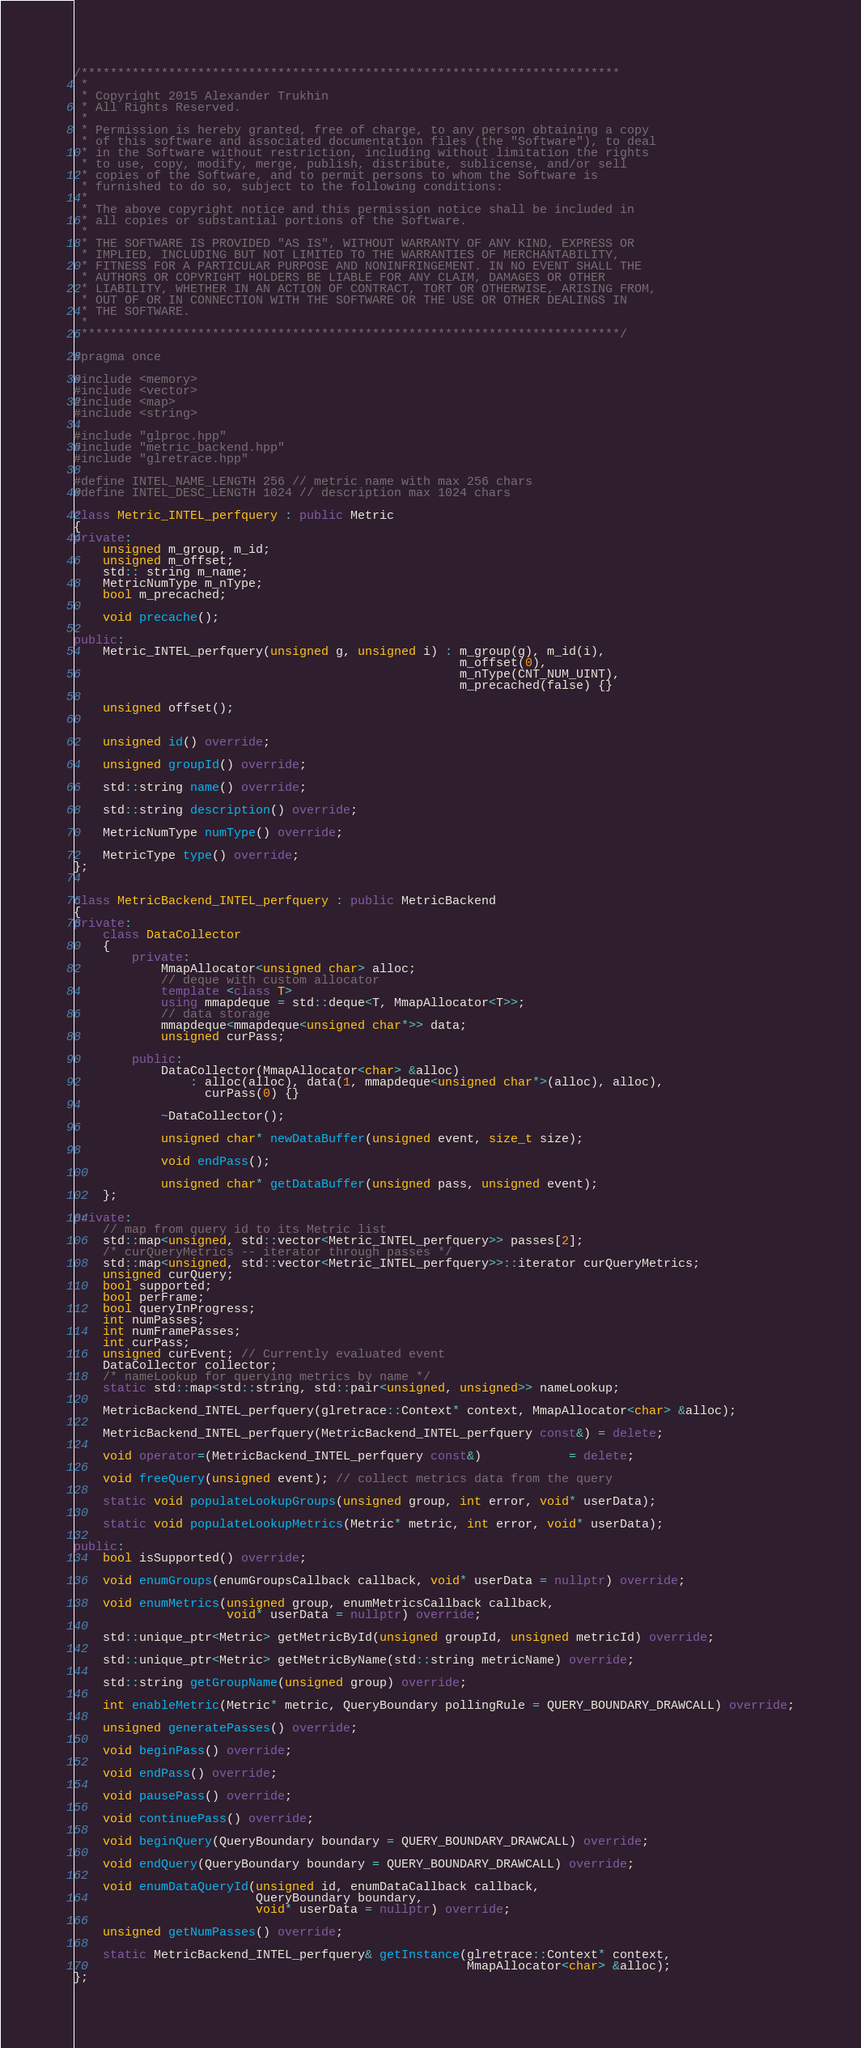Convert code to text. <code><loc_0><loc_0><loc_500><loc_500><_C++_>/**************************************************************************
 *
 * Copyright 2015 Alexander Trukhin
 * All Rights Reserved.
 *
 * Permission is hereby granted, free of charge, to any person obtaining a copy
 * of this software and associated documentation files (the "Software"), to deal
 * in the Software without restriction, including without limitation the rights
 * to use, copy, modify, merge, publish, distribute, sublicense, and/or sell
 * copies of the Software, and to permit persons to whom the Software is
 * furnished to do so, subject to the following conditions:
 *
 * The above copyright notice and this permission notice shall be included in
 * all copies or substantial portions of the Software.
 *
 * THE SOFTWARE IS PROVIDED "AS IS", WITHOUT WARRANTY OF ANY KIND, EXPRESS OR
 * IMPLIED, INCLUDING BUT NOT LIMITED TO THE WARRANTIES OF MERCHANTABILITY,
 * FITNESS FOR A PARTICULAR PURPOSE AND NONINFRINGEMENT. IN NO EVENT SHALL THE
 * AUTHORS OR COPYRIGHT HOLDERS BE LIABLE FOR ANY CLAIM, DAMAGES OR OTHER
 * LIABILITY, WHETHER IN AN ACTION OF CONTRACT, TORT OR OTHERWISE, ARISING FROM,
 * OUT OF OR IN CONNECTION WITH THE SOFTWARE OR THE USE OR OTHER DEALINGS IN
 * THE SOFTWARE.
 *
 **************************************************************************/

#pragma once

#include <memory>
#include <vector>
#include <map>
#include <string>

#include "glproc.hpp"
#include "metric_backend.hpp"
#include "glretrace.hpp"

#define INTEL_NAME_LENGTH 256 // metric name with max 256 chars
#define INTEL_DESC_LENGTH 1024 // description max 1024 chars

class Metric_INTEL_perfquery : public Metric
{
private:
    unsigned m_group, m_id;
    unsigned m_offset;
    std:: string m_name;
    MetricNumType m_nType;
    bool m_precached;

    void precache();

public:
    Metric_INTEL_perfquery(unsigned g, unsigned i) : m_group(g), m_id(i),
                                                     m_offset(0),
                                                     m_nType(CNT_NUM_UINT),
                                                     m_precached(false) {}

    unsigned offset();


    unsigned id() override;

    unsigned groupId() override;

    std::string name() override;

    std::string description() override;

    MetricNumType numType() override;

    MetricType type() override;
};


class MetricBackend_INTEL_perfquery : public MetricBackend
{
private:
    class DataCollector
    {
        private:
            MmapAllocator<unsigned char> alloc;
            // deque with custom allocator
            template <class T>
            using mmapdeque = std::deque<T, MmapAllocator<T>>;
            // data storage
            mmapdeque<mmapdeque<unsigned char*>> data;
            unsigned curPass;

        public:
            DataCollector(MmapAllocator<char> &alloc)
                : alloc(alloc), data(1, mmapdeque<unsigned char*>(alloc), alloc),
                  curPass(0) {}

            ~DataCollector();

            unsigned char* newDataBuffer(unsigned event, size_t size);

            void endPass();

            unsigned char* getDataBuffer(unsigned pass, unsigned event);
    };

private:
    // map from query id to its Metric list
    std::map<unsigned, std::vector<Metric_INTEL_perfquery>> passes[2];
    /* curQueryMetrics -- iterator through passes */
    std::map<unsigned, std::vector<Metric_INTEL_perfquery>>::iterator curQueryMetrics;
    unsigned curQuery;
    bool supported;
    bool perFrame;
    bool queryInProgress;
    int numPasses;
    int numFramePasses;
    int curPass;
    unsigned curEvent; // Currently evaluated event
    DataCollector collector;
    /* nameLookup for querying metrics by name */
    static std::map<std::string, std::pair<unsigned, unsigned>> nameLookup;

    MetricBackend_INTEL_perfquery(glretrace::Context* context, MmapAllocator<char> &alloc);

    MetricBackend_INTEL_perfquery(MetricBackend_INTEL_perfquery const&) = delete;

    void operator=(MetricBackend_INTEL_perfquery const&)            = delete;

    void freeQuery(unsigned event); // collect metrics data from the query

    static void populateLookupGroups(unsigned group, int error, void* userData);

    static void populateLookupMetrics(Metric* metric, int error, void* userData);

public:
    bool isSupported() override;

    void enumGroups(enumGroupsCallback callback, void* userData = nullptr) override;

    void enumMetrics(unsigned group, enumMetricsCallback callback,
                     void* userData = nullptr) override;

    std::unique_ptr<Metric> getMetricById(unsigned groupId, unsigned metricId) override;

    std::unique_ptr<Metric> getMetricByName(std::string metricName) override;

    std::string getGroupName(unsigned group) override;

    int enableMetric(Metric* metric, QueryBoundary pollingRule = QUERY_BOUNDARY_DRAWCALL) override;

    unsigned generatePasses() override;

    void beginPass() override;

    void endPass() override;

    void pausePass() override;

    void continuePass() override;

    void beginQuery(QueryBoundary boundary = QUERY_BOUNDARY_DRAWCALL) override;

    void endQuery(QueryBoundary boundary = QUERY_BOUNDARY_DRAWCALL) override;

    void enumDataQueryId(unsigned id, enumDataCallback callback,
                         QueryBoundary boundary,
                         void* userData = nullptr) override;

    unsigned getNumPasses() override;

    static MetricBackend_INTEL_perfquery& getInstance(glretrace::Context* context,
                                                      MmapAllocator<char> &alloc);
};

</code> 